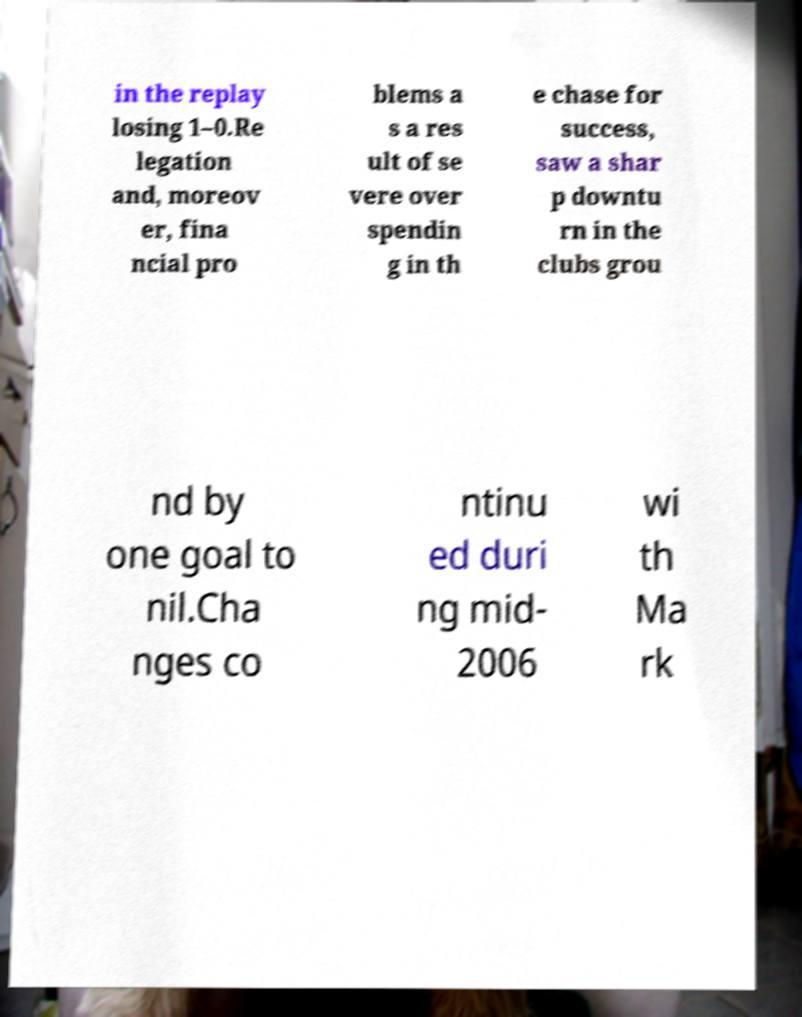I need the written content from this picture converted into text. Can you do that? in the replay losing 1–0.Re legation and, moreov er, fina ncial pro blems a s a res ult of se vere over spendin g in th e chase for success, saw a shar p downtu rn in the clubs grou nd by one goal to nil.Cha nges co ntinu ed duri ng mid- 2006 wi th Ma rk 